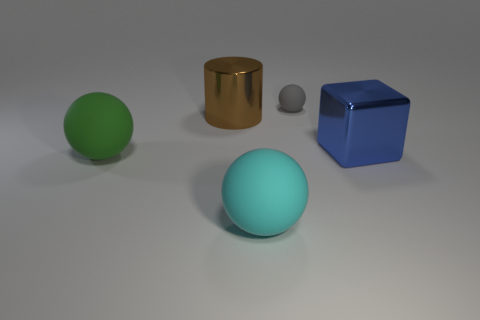How big is the sphere behind the shiny block that is right of the shiny object that is behind the big blue object?
Provide a succinct answer. Small. What number of green things are the same material as the large cyan ball?
Keep it short and to the point. 1. The big metal thing to the left of the matte sphere that is behind the blue metallic object is what color?
Your response must be concise. Brown. How many things are either blue metallic cylinders or big matte objects right of the large brown metallic thing?
Ensure brevity in your answer.  1. Is there another cylinder of the same color as the big cylinder?
Offer a very short reply. No. How many blue things are large matte things or metallic cylinders?
Ensure brevity in your answer.  0. What number of other objects are the same size as the green object?
Your answer should be very brief. 3. How many big things are matte spheres or green things?
Your answer should be compact. 2. There is a brown object; is it the same size as the rubber sphere that is behind the large blue block?
Your response must be concise. No. How many other objects are the same shape as the large blue shiny thing?
Offer a very short reply. 0. 